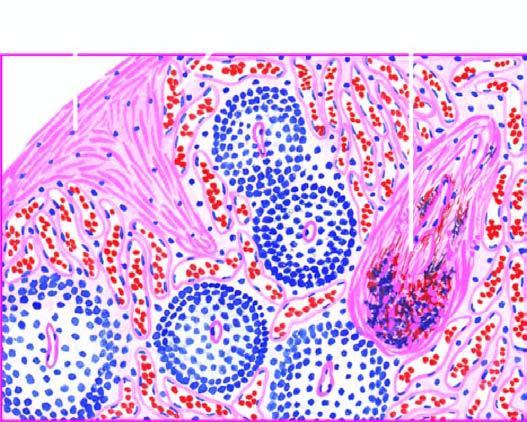s gamna-gandy body also seen?
Answer the question using a single word or phrase. Yes 